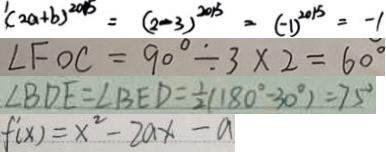Convert formula to latex. <formula><loc_0><loc_0><loc_500><loc_500>^ { 1 } ( 2 a + b ) ^ { 2 0 1 5 } = ( 2 - 3 ) ^ { 2 0 1 5 } = ( - 1 ) ^ { 2 0 1 5 } = - 1 
 \angle F O C = 9 0 ^ { \circ } \div 3 \times 2 = 6 0 ^ { \circ } 
 \angle B D E = \angle B E D = \frac { 1 } { 2 } ( 1 8 0 ^ { \circ } - 3 0 ^ { \circ } ) = 7 5 ^ { \circ } 
 f ^ { \prime } ( x ) = x ^ { 2 } - 2 a x - a</formula> 